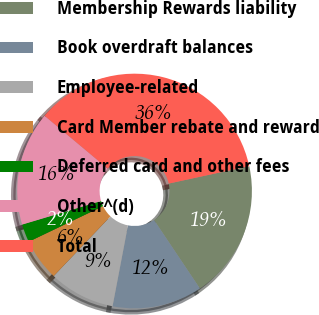Convert chart. <chart><loc_0><loc_0><loc_500><loc_500><pie_chart><fcel>Membership Rewards liability<fcel>Book overdraft balances<fcel>Employee-related<fcel>Card Member rebate and reward<fcel>Deferred card and other fees<fcel>Other^(d)<fcel>Total<nl><fcel>19.0%<fcel>12.4%<fcel>9.1%<fcel>5.79%<fcel>2.49%<fcel>15.7%<fcel>35.51%<nl></chart> 